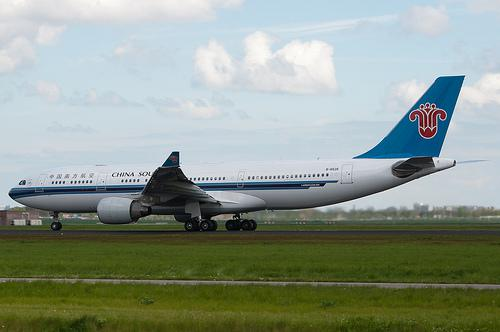Question: what color is the grass?
Choices:
A. Yellow.
B. Green.
C. Brown.
D. Grey.
Answer with the letter. Answer: B Question: what type of object is it?
Choices:
A. Plane.
B. Ball.
C. Box.
D. Bicycle.
Answer with the letter. Answer: A Question: what time is it?
Choices:
A. Noon.
B. Daytime.
C. Sunset.
D. Sunrise.
Answer with the letter. Answer: B Question: where is the plane?
Choices:
A. In the city.
B. In the air.
C. On the runway.
D. Inside.
Answer with the letter. Answer: C 